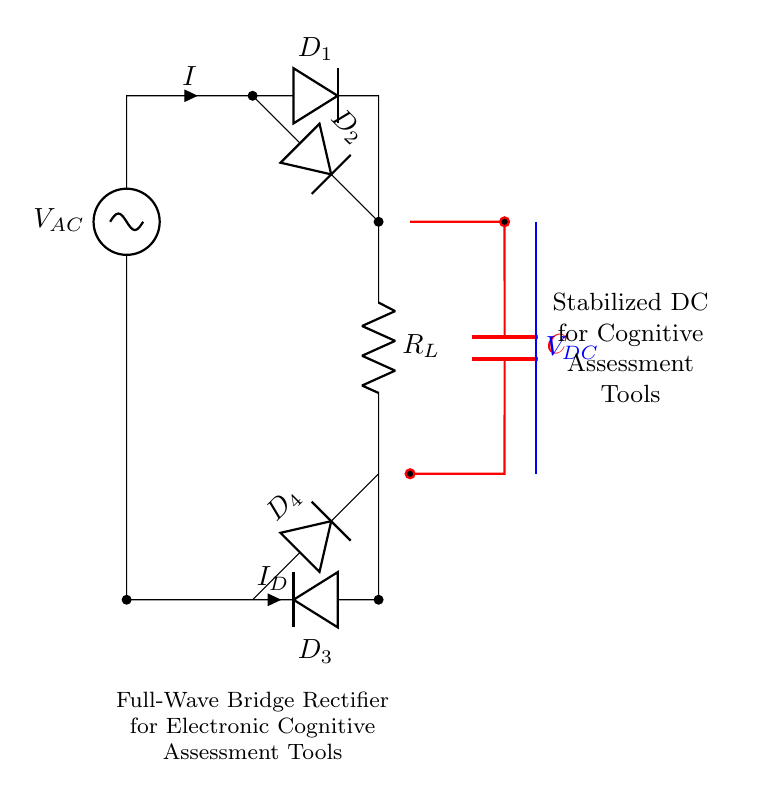What is the circuit type depicted? The circuit type shown is a full-wave bridge rectifier. This is determined by the arrangement of diodes and how they manage alternating current input to produce direct current output through the bridge configuration.
Answer: full-wave bridge rectifier What are the components used in this circuit? The components include four diodes, a resistor, and a capacitor. These elements can be identified within the diagram, with each diode labeled distinctly and the resistor and capacitor indicated clearly.
Answer: four diodes, a resistor, a capacitor What does the capacitor do in this circuit? The capacitor functions to stabilize the output voltage. By charging and discharging, it smooths out the fluctuations in the current received from the rectifier, which results in a more steady DC output.
Answer: stabilize output voltage What is the purpose of this rectifier in relation to cognitive assessment tools? The purpose is to provide stabilized direct current power supply for the tools, ensuring they operate reliably without voltage fluctuations that could affect performance or results.
Answer: stabilized DC power supply What is the current direction through diode D1? The current flows from the AC voltage source into diode D1 and continues through the circuit as it conducts during the positive half cycle of the input AC. This identifies D1's role in the rectification process during this cycle.
Answer: towards R_L How many diodes are conducting during one half of the AC cycle? During one half of the AC cycle, two diodes conduct while the other two are reverse biased. This configuration allows the bridge rectifier to maintain a continuous output even as the input AC alternates.
Answer: two diodes What is the output voltage denoted in the circuit? The output voltage is labeled as V_DC, which refers to the stabilized direct current voltage generated after rectification and smoothing from the alternating current input.
Answer: V_DC 